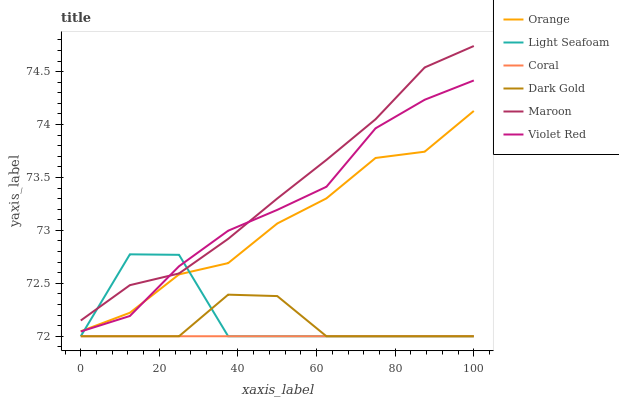Does Coral have the minimum area under the curve?
Answer yes or no. Yes. Does Maroon have the maximum area under the curve?
Answer yes or no. Yes. Does Dark Gold have the minimum area under the curve?
Answer yes or no. No. Does Dark Gold have the maximum area under the curve?
Answer yes or no. No. Is Coral the smoothest?
Answer yes or no. Yes. Is Light Seafoam the roughest?
Answer yes or no. Yes. Is Dark Gold the smoothest?
Answer yes or no. No. Is Dark Gold the roughest?
Answer yes or no. No. Does Dark Gold have the lowest value?
Answer yes or no. Yes. Does Maroon have the lowest value?
Answer yes or no. No. Does Maroon have the highest value?
Answer yes or no. Yes. Does Dark Gold have the highest value?
Answer yes or no. No. Is Dark Gold less than Orange?
Answer yes or no. Yes. Is Maroon greater than Dark Gold?
Answer yes or no. Yes. Does Coral intersect Dark Gold?
Answer yes or no. Yes. Is Coral less than Dark Gold?
Answer yes or no. No. Is Coral greater than Dark Gold?
Answer yes or no. No. Does Dark Gold intersect Orange?
Answer yes or no. No. 